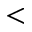Convert formula to latex. <formula><loc_0><loc_0><loc_500><loc_500><</formula> 